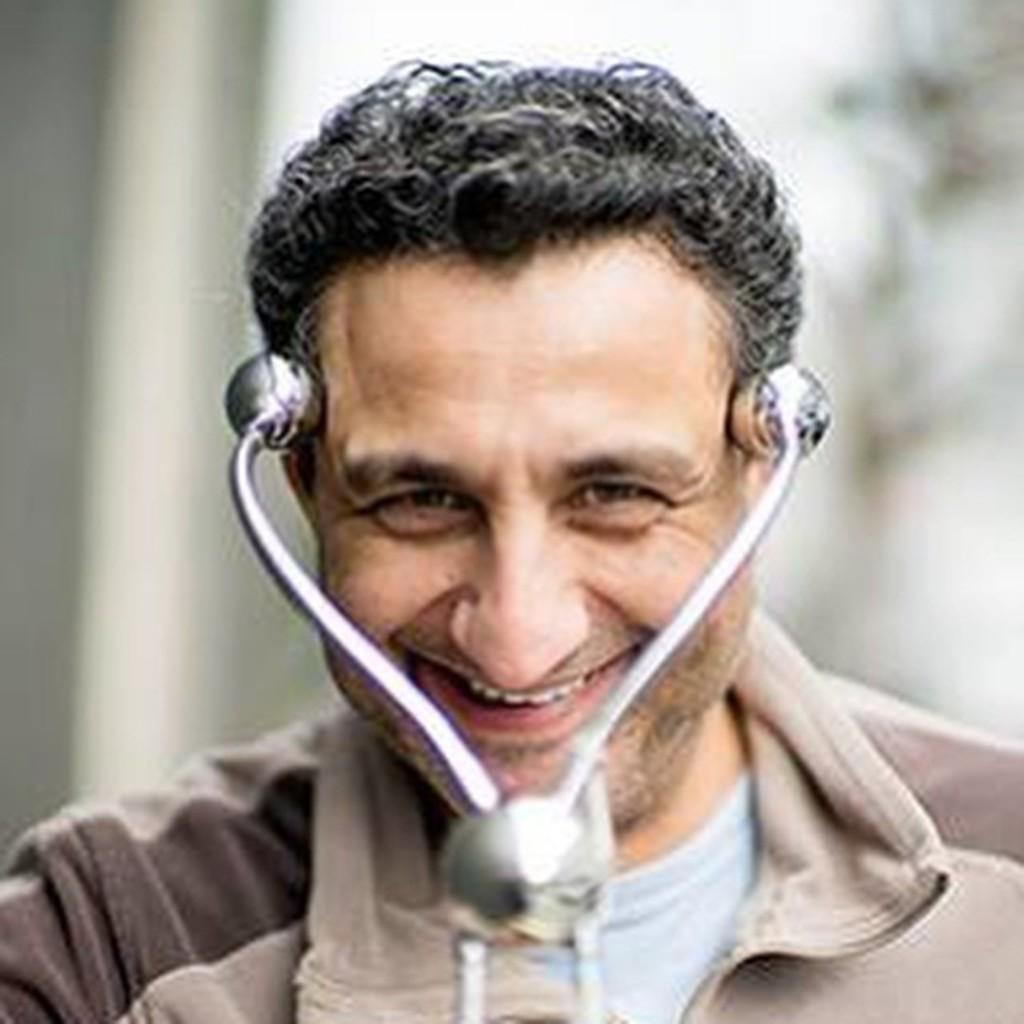Who or what is the main subject of the image? There is a person in the image. What is the person doing or expressing in the image? The person is smiling. Can you identify any objects in the image that might be related to the person's profession or activity? There is an object that looks like a stethoscope in the image. How would you describe the background of the image? The background of the image is blurred. What type of spot can be seen on the person's daughter in the image? There is no daughter present in the image, and therefore no spot can be seen on her. What is the color of the copper object in the image? There is no copper object present in the image. 